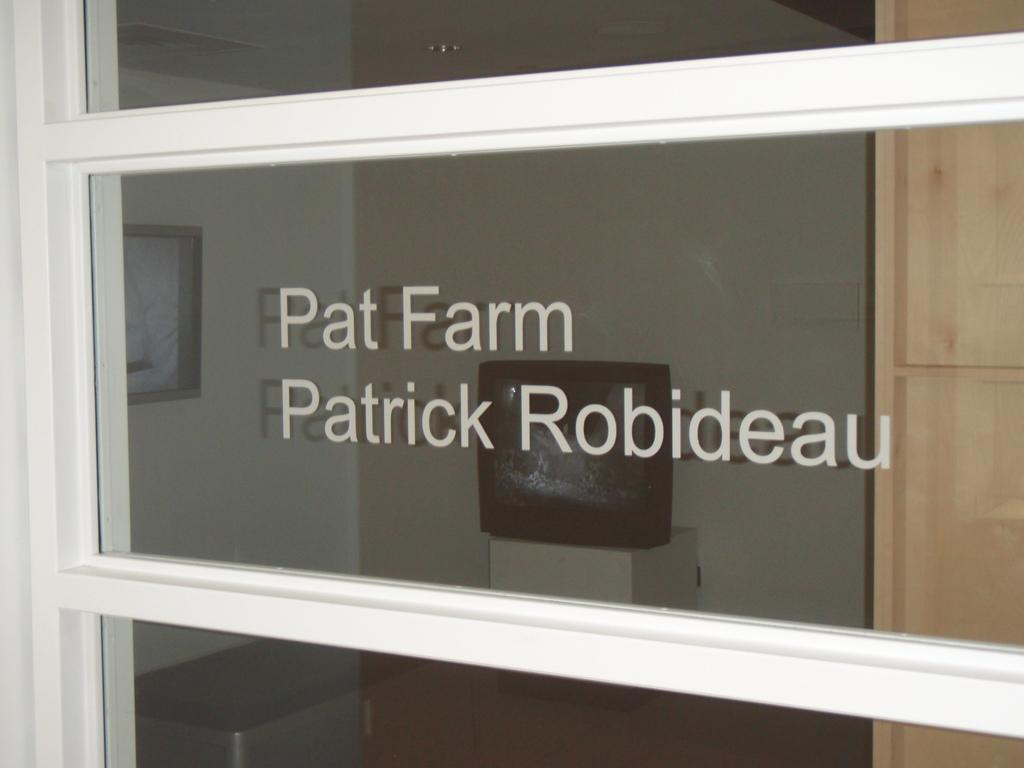What is inside the glass that is visible in the image? The facts do not specify what is inside the glass, only that there is text on it. What can be seen hanging on the wall in the image? There is a frame on the wall in the image. What is the object on the platform in the image? The facts only mention that there is an object on a platform, but do not specify what it is. What type of coat is hanging on the wall in the image? There is no coat present in the image; only a frame is mentioned on the wall. What reward is being offered for finding the missing object in the image? There is no mention of a missing object or a reward in the image or the provided facts. 